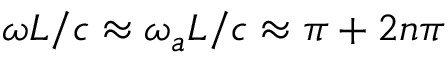<formula> <loc_0><loc_0><loc_500><loc_500>\omega L / c \approx \omega _ { a } L / c \approx \pi + 2 n \pi</formula> 